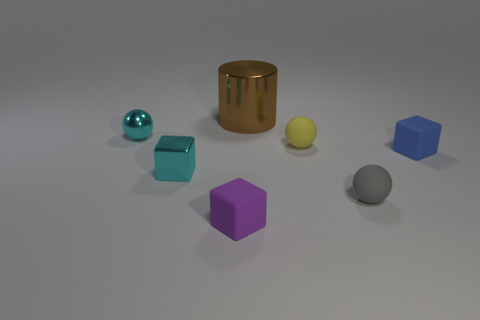What is the size of the thing that is to the left of the small yellow sphere and right of the tiny purple matte cube?
Ensure brevity in your answer.  Large. There is a object that is behind the gray thing and right of the small yellow rubber object; what shape is it?
Ensure brevity in your answer.  Cube. Are there fewer yellow rubber things that are in front of the purple rubber cube than big brown rubber cylinders?
Provide a short and direct response. No. There is a tiny matte object that is both left of the small gray matte thing and behind the tiny gray rubber ball; what color is it?
Your answer should be very brief. Yellow. What number of other objects are the same shape as the large brown metal thing?
Provide a short and direct response. 0. Is the number of cubes that are behind the metallic sphere less than the number of small spheres that are behind the big brown metallic thing?
Keep it short and to the point. No. Is the material of the gray object the same as the cyan sphere behind the gray ball?
Your response must be concise. No. Are there more tiny blue rubber objects than cyan metallic objects?
Make the answer very short. No. What is the shape of the object that is on the right side of the tiny sphere in front of the block that is right of the large brown metal cylinder?
Your answer should be very brief. Cube. Do the small cube left of the purple block and the brown cylinder that is left of the blue block have the same material?
Your answer should be very brief. Yes. 